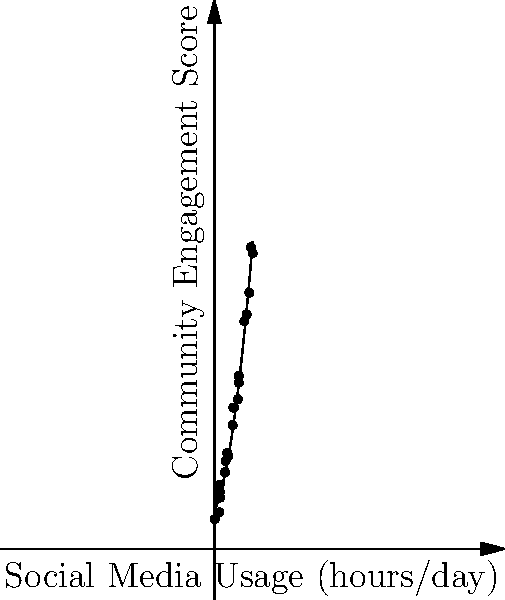A social scientist is analyzing the relationship between daily social media usage and community engagement scores. The scatter plot shows the collected data points, and a best-fit curve has been added. If the best-fit curve is given by the function $f(x) = 0.5x^2 + 2x + 10$, where $x$ represents daily social media usage in hours and $f(x)$ represents the community engagement score, at what rate is the community engagement score changing when social media usage is 4 hours per day? To find the rate of change of the community engagement score with respect to social media usage at 4 hours per day, we need to follow these steps:

1) The rate of change is represented by the derivative of the function $f(x)$ at $x = 4$.

2) First, let's find the derivative of $f(x)$:
   $f(x) = 0.5x^2 + 2x + 10$
   $f'(x) = 1x + 2$ (using the power rule and constant rule of differentiation)

3) Now, we need to evaluate $f'(x)$ at $x = 4$:
   $f'(4) = 1(4) + 2 = 4 + 2 = 6$

4) Interpret the result: When social media usage is 4 hours per day, the community engagement score is changing at a rate of 6 points per hour of additional social media usage.
Answer: 6 points per hour 